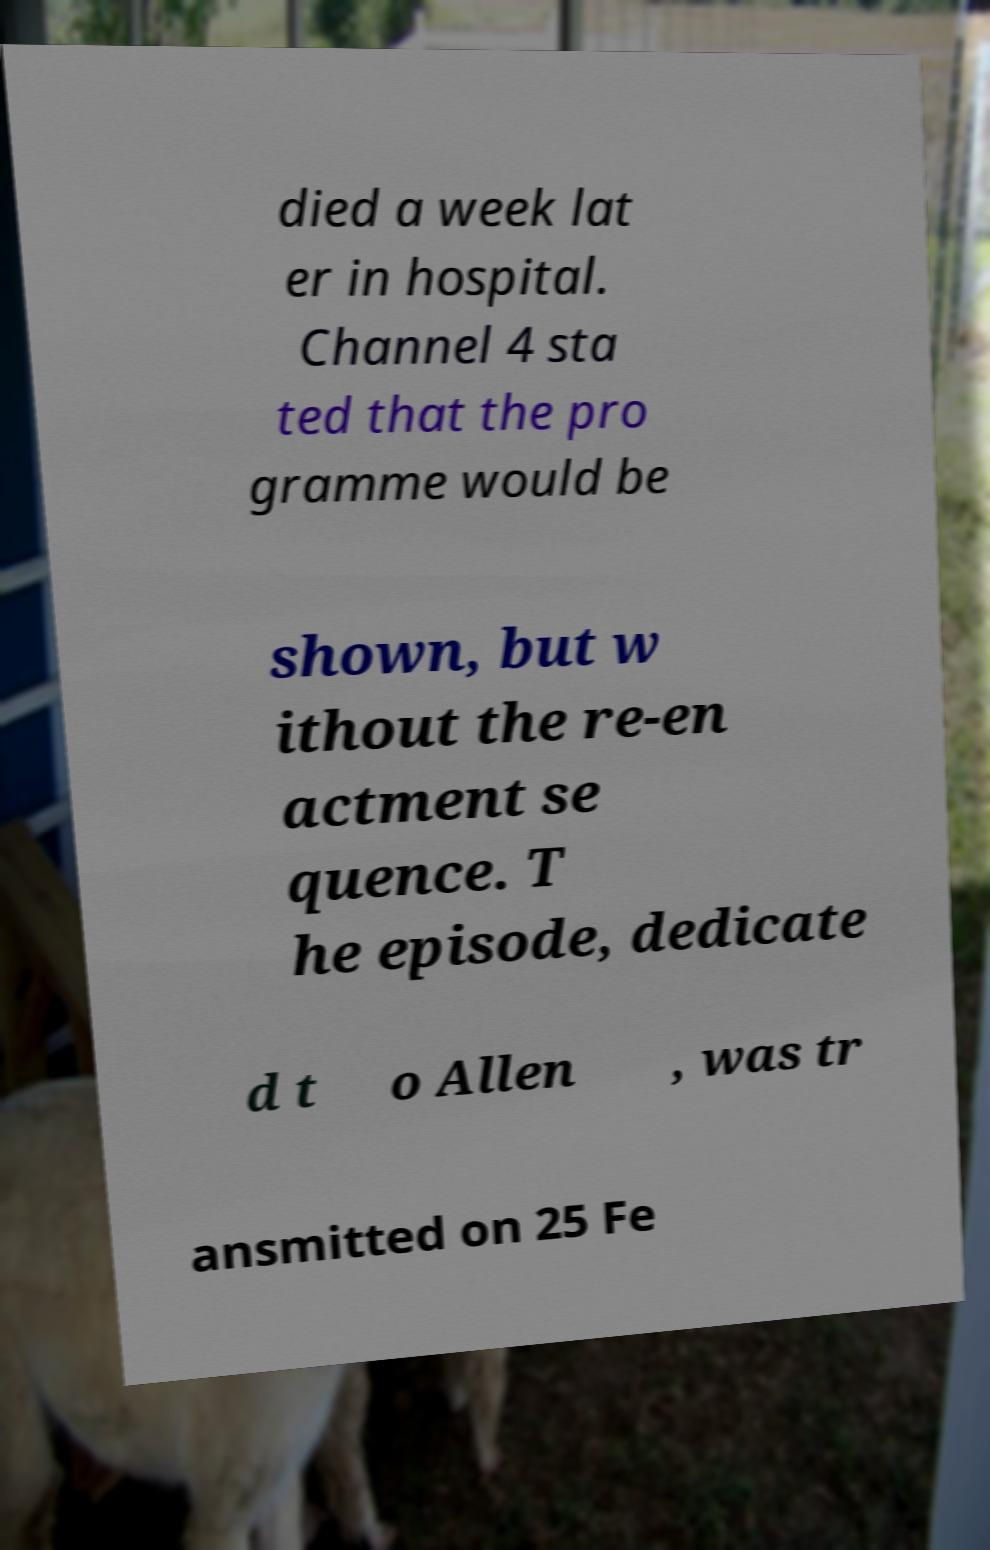What messages or text are displayed in this image? I need them in a readable, typed format. died a week lat er in hospital. Channel 4 sta ted that the pro gramme would be shown, but w ithout the re-en actment se quence. T he episode, dedicate d t o Allen , was tr ansmitted on 25 Fe 